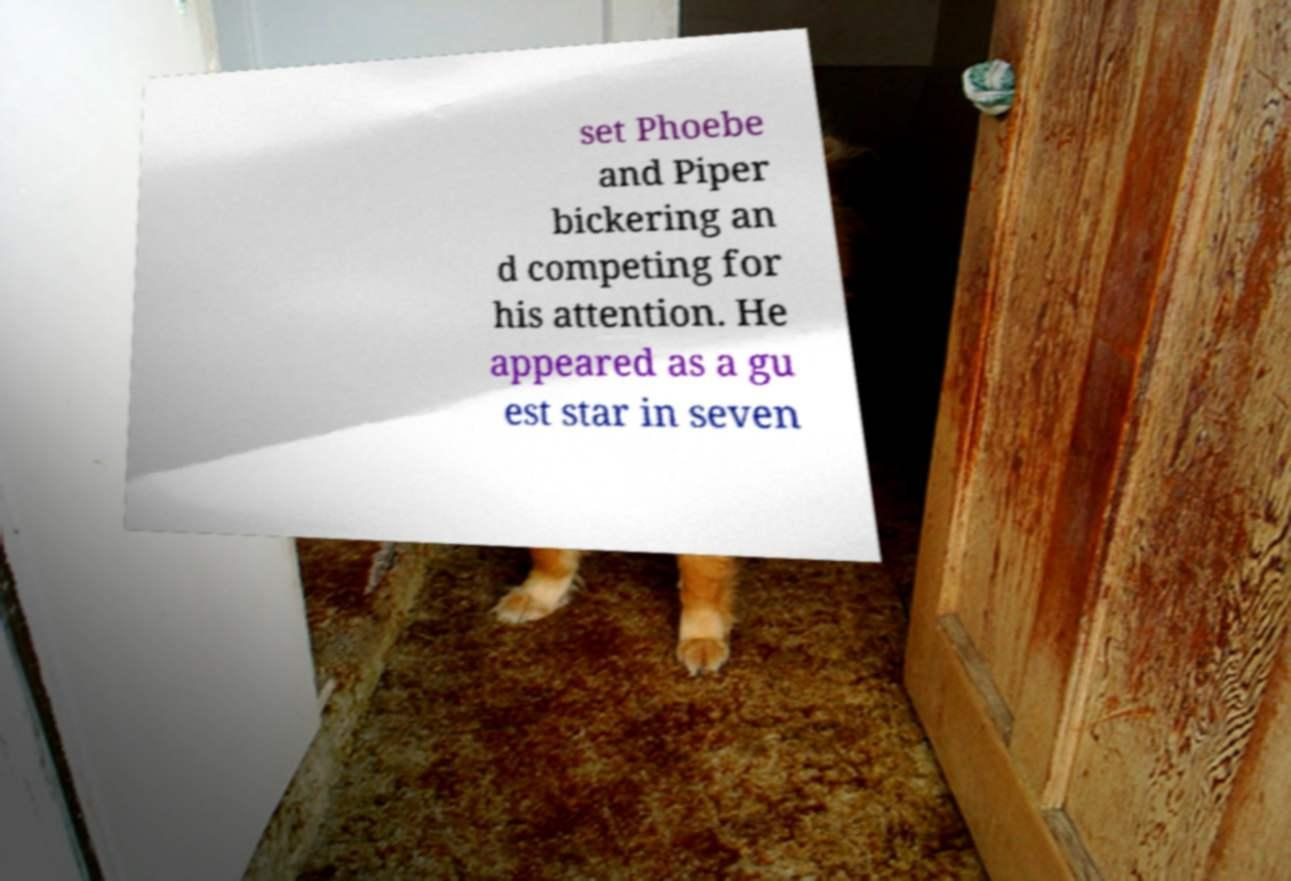What messages or text are displayed in this image? I need them in a readable, typed format. set Phoebe and Piper bickering an d competing for his attention. He appeared as a gu est star in seven 